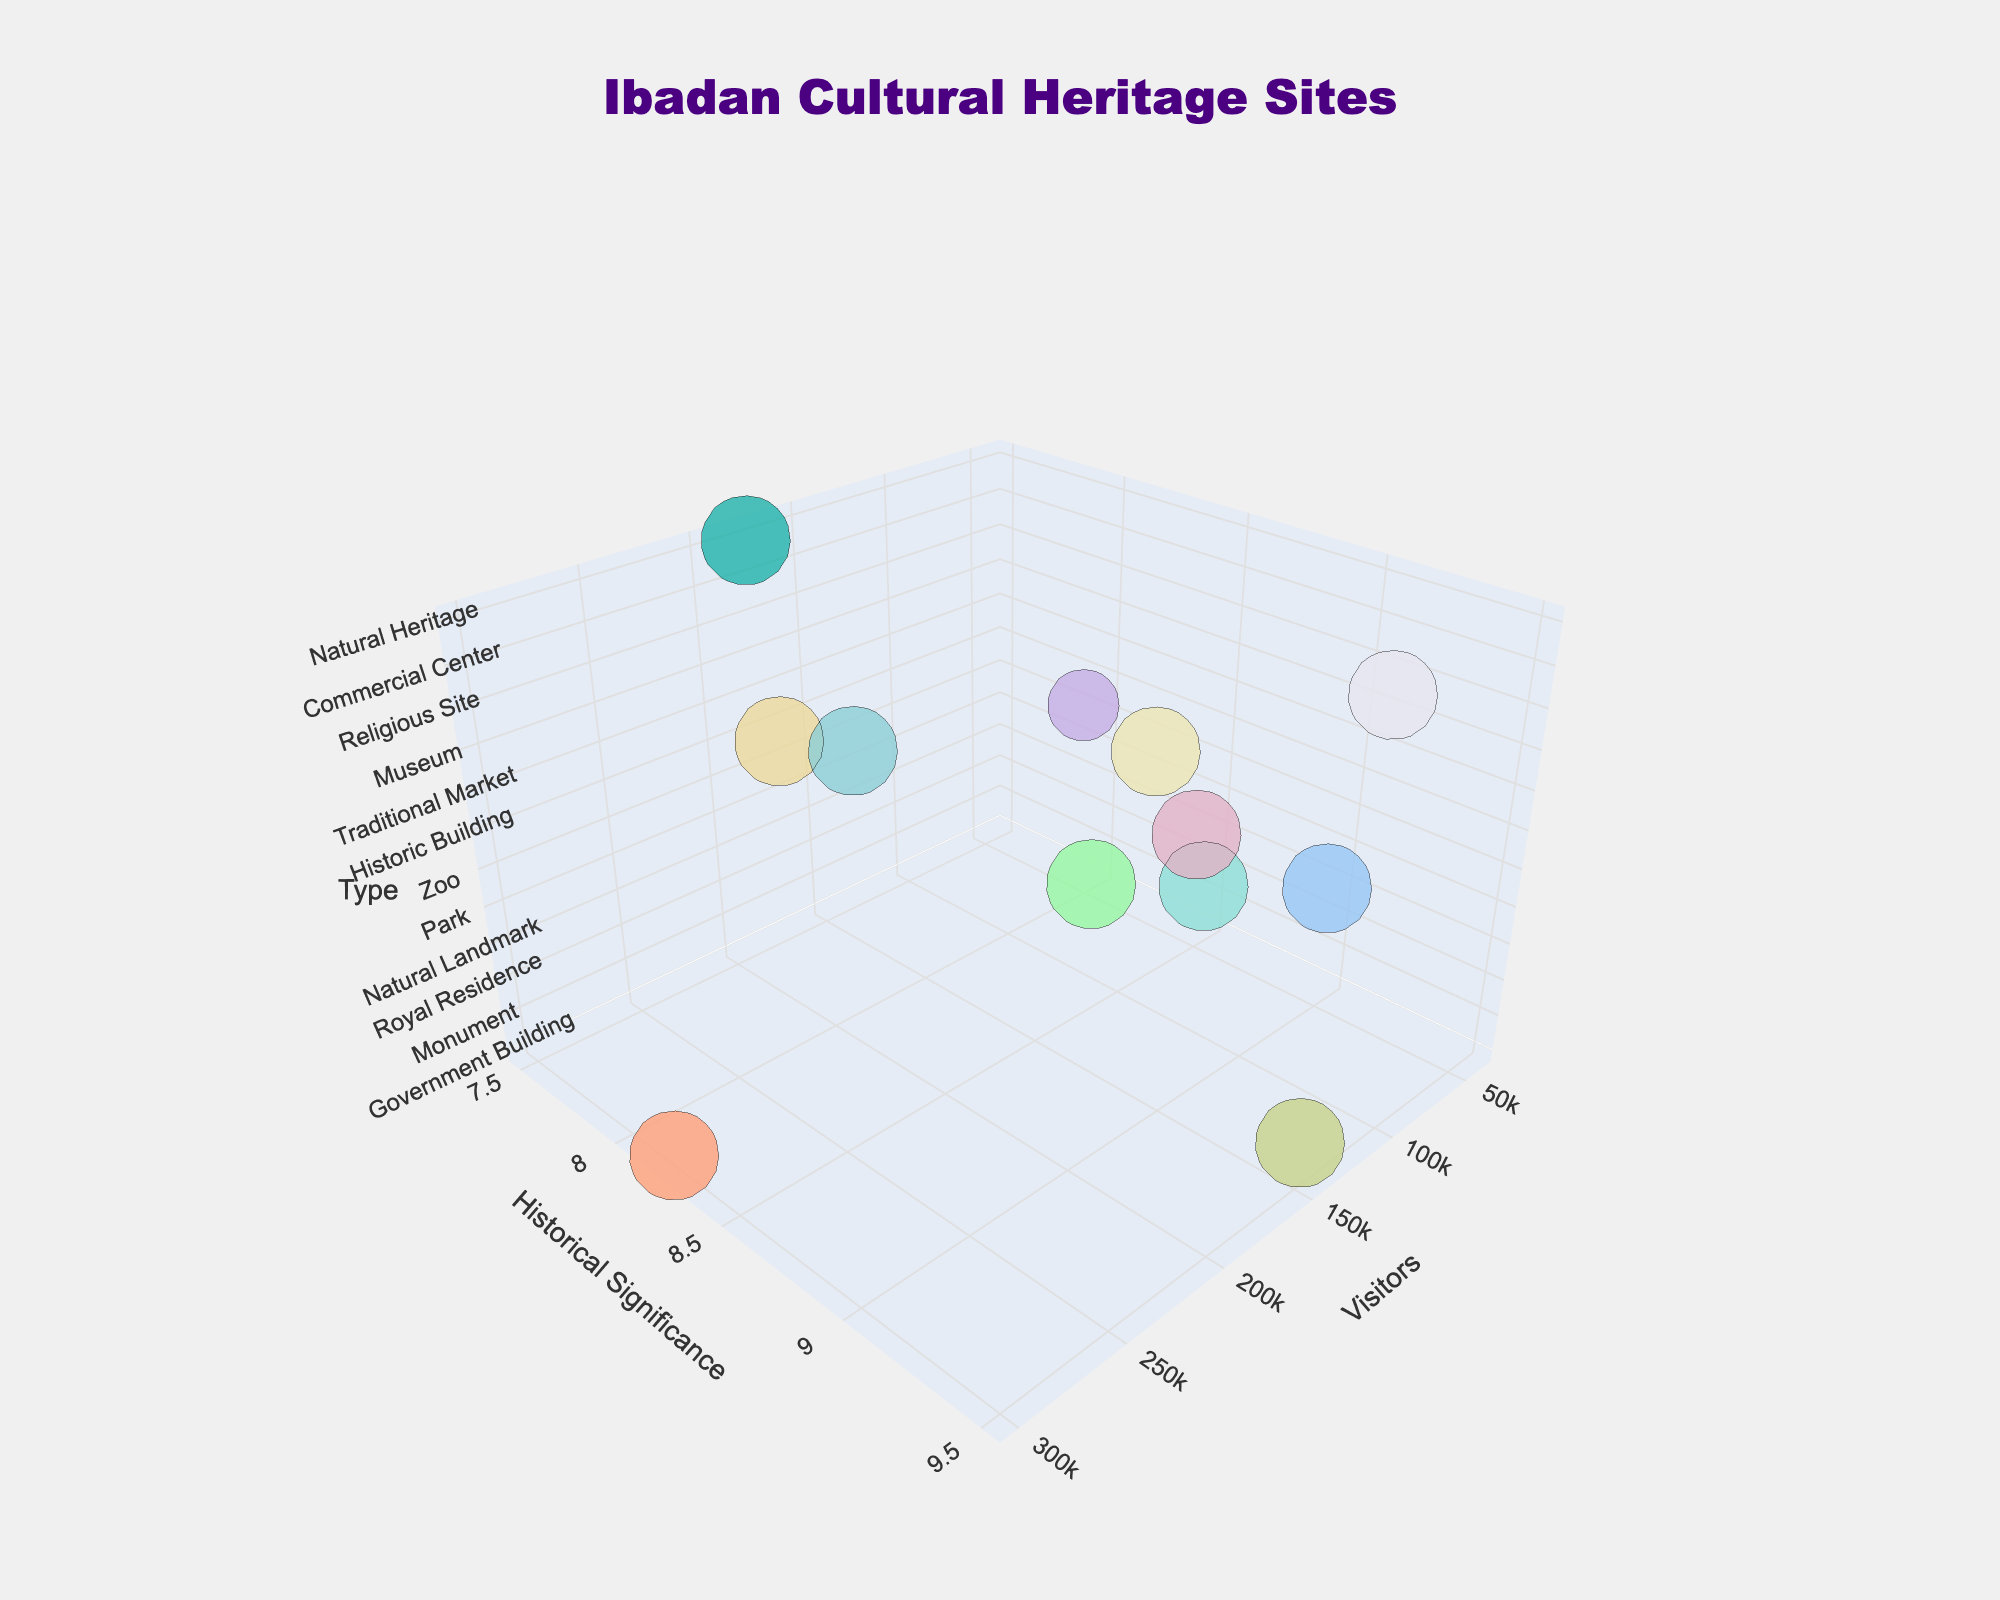What is the title of the figure? The title is typically located at the top of the figure. It reads "Ibadan Cultural Heritage Sites".
Answer: Ibadan Cultural Heritage Sites What do the x, y, and z axes represent? The x-axis represents the number of visitors, the y-axis represents the historical significance, and the z-axis represents the type of cultural site.
Answer: Visitors, Historical Significance, Type Which cultural heritage site has the highest number of visitors? Look for the data point with the highest value on the x-axis. The one with 300,000 visitors is Dugbe Market.
Answer: Dugbe Market Which site has the highest historical significance? Look for the data point with the highest value on the y-axis. The site with a historical significance rating of 9.5 is Mapo Hall.
Answer: Mapo Hall How many cultural site types are represented in the figure? Count the distinct values on the z-axis using either tick values or color variations (there are 8 types).
Answer: Eight Among Oje Market and Irefin Palace, which has a higher historical significance? Compare the y-axis values for Oje Market (8.6) and Irefin Palace (9.2).
Answer: Irefin Palace What is the average historical significance of all the sites shown? Sum all historical significance values and divide by the number of sites. (9.5 + 8.7 + 9.2 + 8.9 + 7.8 + 7.5 + 8.3 + 8.6 + 9.1 + 8.8 + 8.2 + 7.9) / 12 = 104.5 / 12.
Answer: 8.71 Which type of site has both a high number of visitors and high historical significance? Look at the cultural site with a large x value and high y values; Example: Mapo Hall (150,000 visitors, 9.5 significance).
Answer: Mapo Hall (Government Building) Are the natural heritage sites generally rated higher in historical significance than other types? Compare the y-axis values of all data points classified as 'Natural Landmark' (8.9) and 'Natural Heritage' (7.9) with other types. They are slightly lower or comparable.
Answer: No 